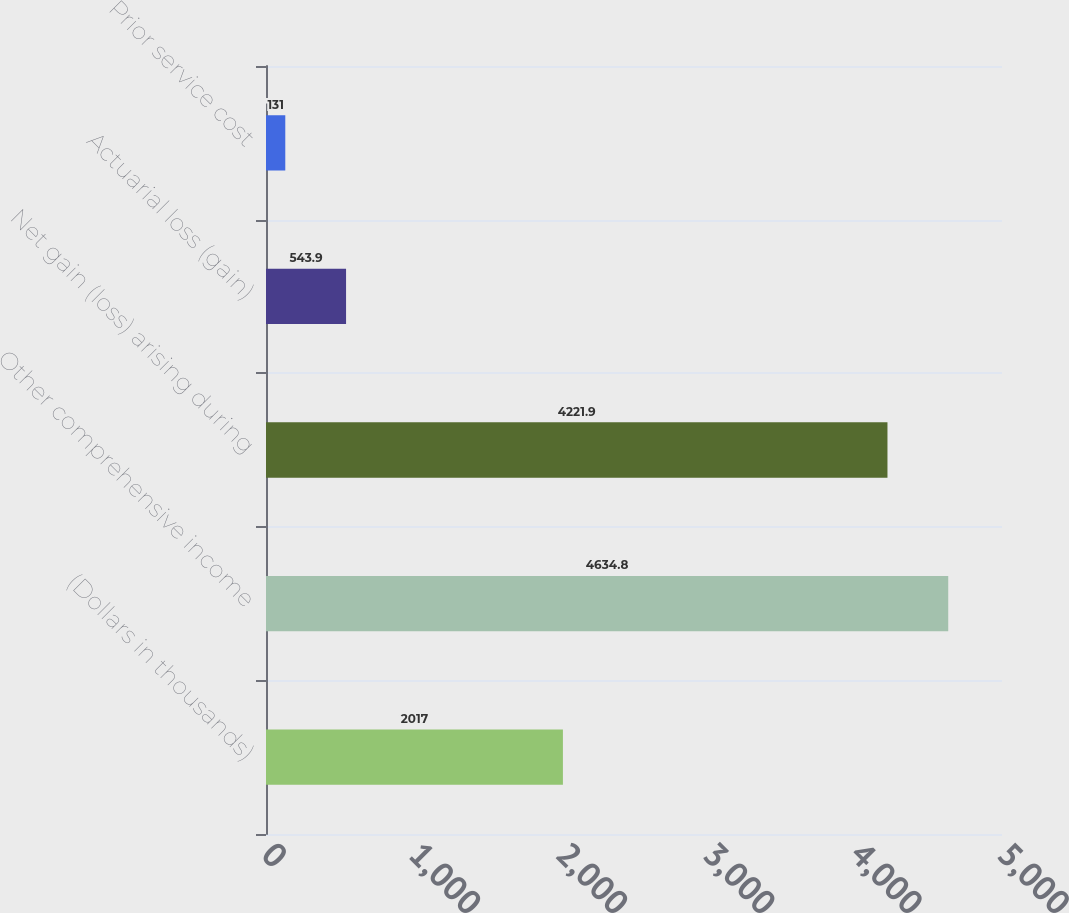<chart> <loc_0><loc_0><loc_500><loc_500><bar_chart><fcel>(Dollars in thousands)<fcel>Other comprehensive income<fcel>Net gain (loss) arising during<fcel>Actuarial loss (gain)<fcel>Prior service cost<nl><fcel>2017<fcel>4634.8<fcel>4221.9<fcel>543.9<fcel>131<nl></chart> 